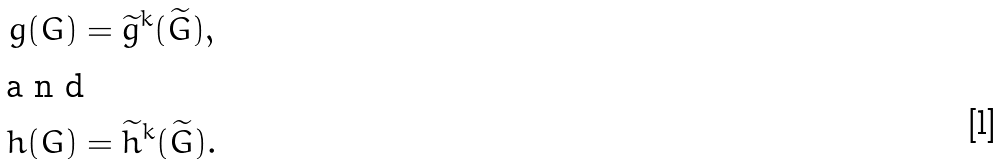Convert formula to latex. <formula><loc_0><loc_0><loc_500><loc_500>g ( G ) & = \widetilde { g } ^ { k } ( \widetilde { G } ) , \\ \intertext { a n d } h ( G ) & = \widetilde { h } ^ { k } ( \widetilde { G } ) .</formula> 